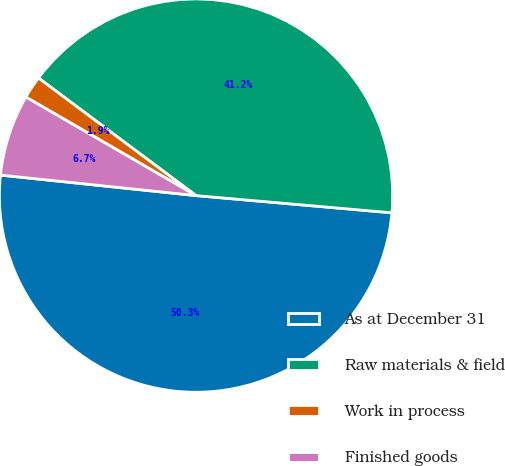<chart> <loc_0><loc_0><loc_500><loc_500><pie_chart><fcel>As at December 31<fcel>Raw materials & field<fcel>Work in process<fcel>Finished goods<nl><fcel>50.27%<fcel>41.19%<fcel>1.85%<fcel>6.69%<nl></chart> 